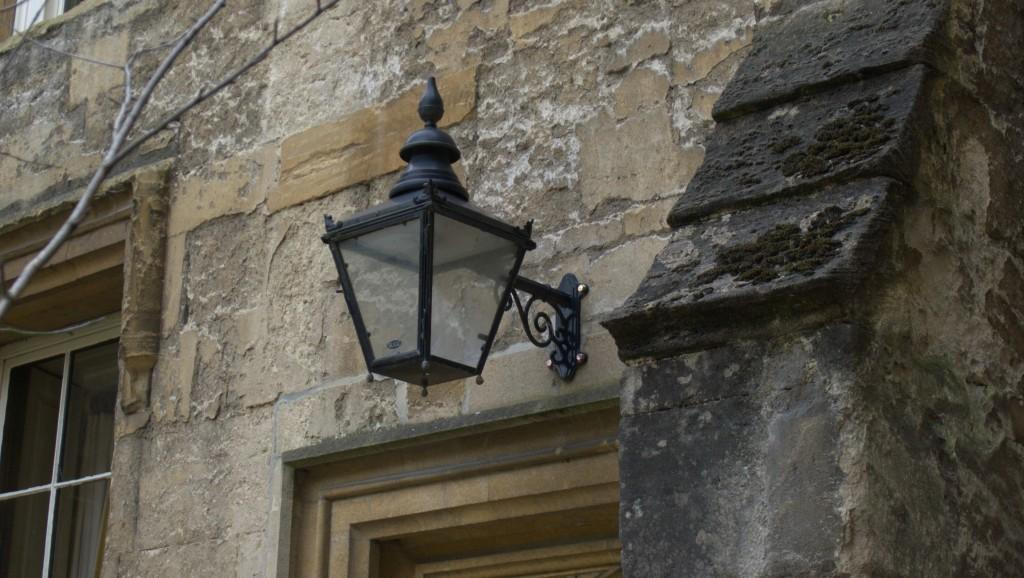What type of lighting fixture is attached to the building in the image? There is a lamp on the wall of the building in the image. What architectural feature can be seen on the bottom left side of the image? There is a glass window on the bottom left side of the image. How many eyes can be seen on the lamp in the image? There are no eyes present on the lamp in the image, as it is a lighting fixture and not a living being. What type of trade is being conducted in the image? There is no indication of any trade being conducted in the image; it primarily features a building with a lamp and a glass window. 